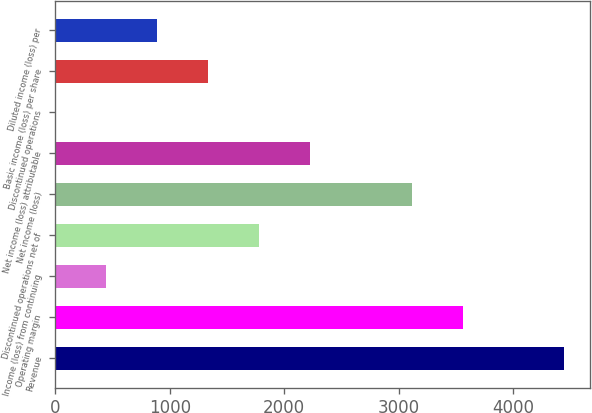Convert chart to OTSL. <chart><loc_0><loc_0><loc_500><loc_500><bar_chart><fcel>Revenue<fcel>Operating margin<fcel>Income (loss) from continuing<fcel>Discontinued operations net of<fcel>Net income (loss)<fcel>Net income (loss) attributable<fcel>Discontinued operations<fcel>Basic income (loss) per share<fcel>Diluted income (loss) per<nl><fcel>4448<fcel>3558.42<fcel>444.82<fcel>1779.22<fcel>3113.62<fcel>2224.02<fcel>0.02<fcel>1334.42<fcel>889.62<nl></chart> 